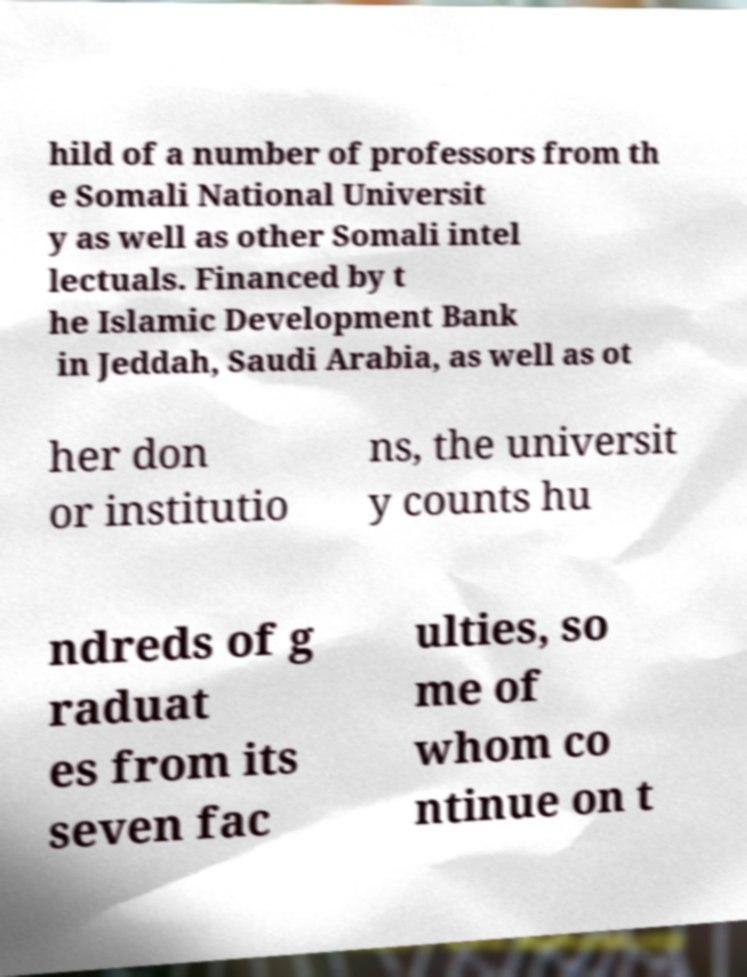For documentation purposes, I need the text within this image transcribed. Could you provide that? hild of a number of professors from th e Somali National Universit y as well as other Somali intel lectuals. Financed by t he Islamic Development Bank in Jeddah, Saudi Arabia, as well as ot her don or institutio ns, the universit y counts hu ndreds of g raduat es from its seven fac ulties, so me of whom co ntinue on t 